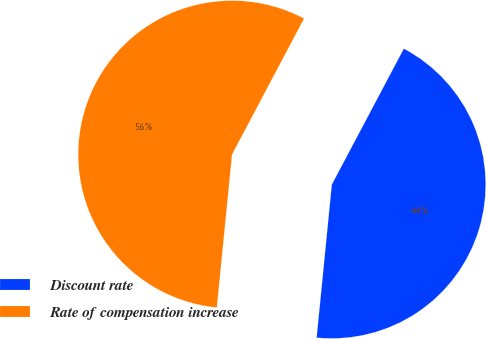Convert chart. <chart><loc_0><loc_0><loc_500><loc_500><pie_chart><fcel>Discount rate<fcel>Rate of compensation increase<nl><fcel>43.82%<fcel>56.18%<nl></chart> 